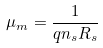Convert formula to latex. <formula><loc_0><loc_0><loc_500><loc_500>\mu _ { m } = \frac { 1 } { q n _ { s } R _ { s } }</formula> 